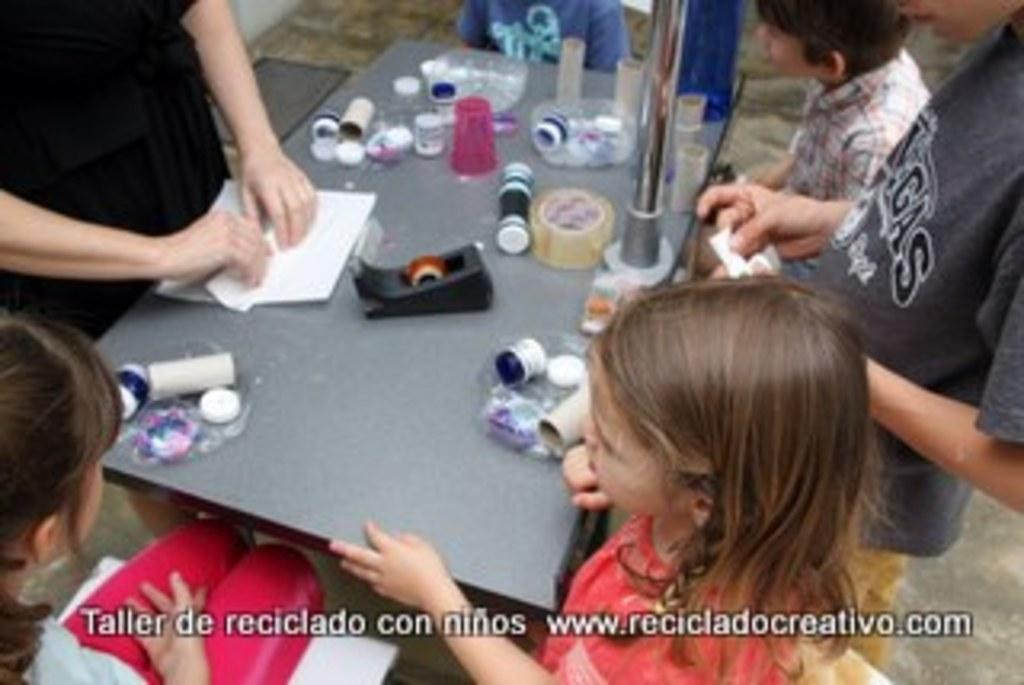How many people are in the image? There is a group of people in the image. What are the people doing in the image? Some people are seated on chairs, while others are standing in front of the seated people. What is on the table in the image? There are plaster objects, papers, and other objects on the table. How does the cable connect the people in the image? There is no cable present in the image; it is a group of people interacting with each other. 